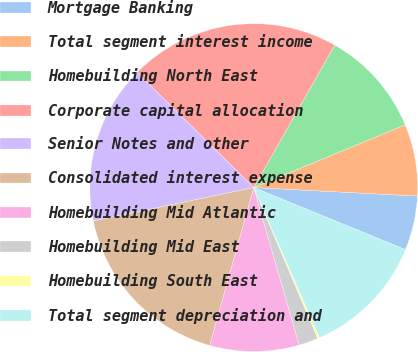Convert chart to OTSL. <chart><loc_0><loc_0><loc_500><loc_500><pie_chart><fcel>Mortgage Banking<fcel>Total segment interest income<fcel>Homebuilding North East<fcel>Corporate capital allocation<fcel>Senior Notes and other<fcel>Consolidated interest expense<fcel>Homebuilding Mid Atlantic<fcel>Homebuilding Mid East<fcel>Homebuilding South East<fcel>Total segment depreciation and<nl><fcel>5.36%<fcel>7.08%<fcel>10.52%<fcel>20.84%<fcel>15.68%<fcel>17.4%<fcel>8.8%<fcel>1.92%<fcel>0.2%<fcel>12.24%<nl></chart> 